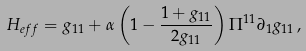<formula> <loc_0><loc_0><loc_500><loc_500>H _ { e f f } = g _ { 1 1 } + \alpha \left ( 1 - \frac { 1 + g _ { 1 1 } } { 2 g _ { 1 1 } } \right ) \Pi ^ { 1 1 } \partial _ { 1 } g _ { 1 1 } \, ,</formula> 